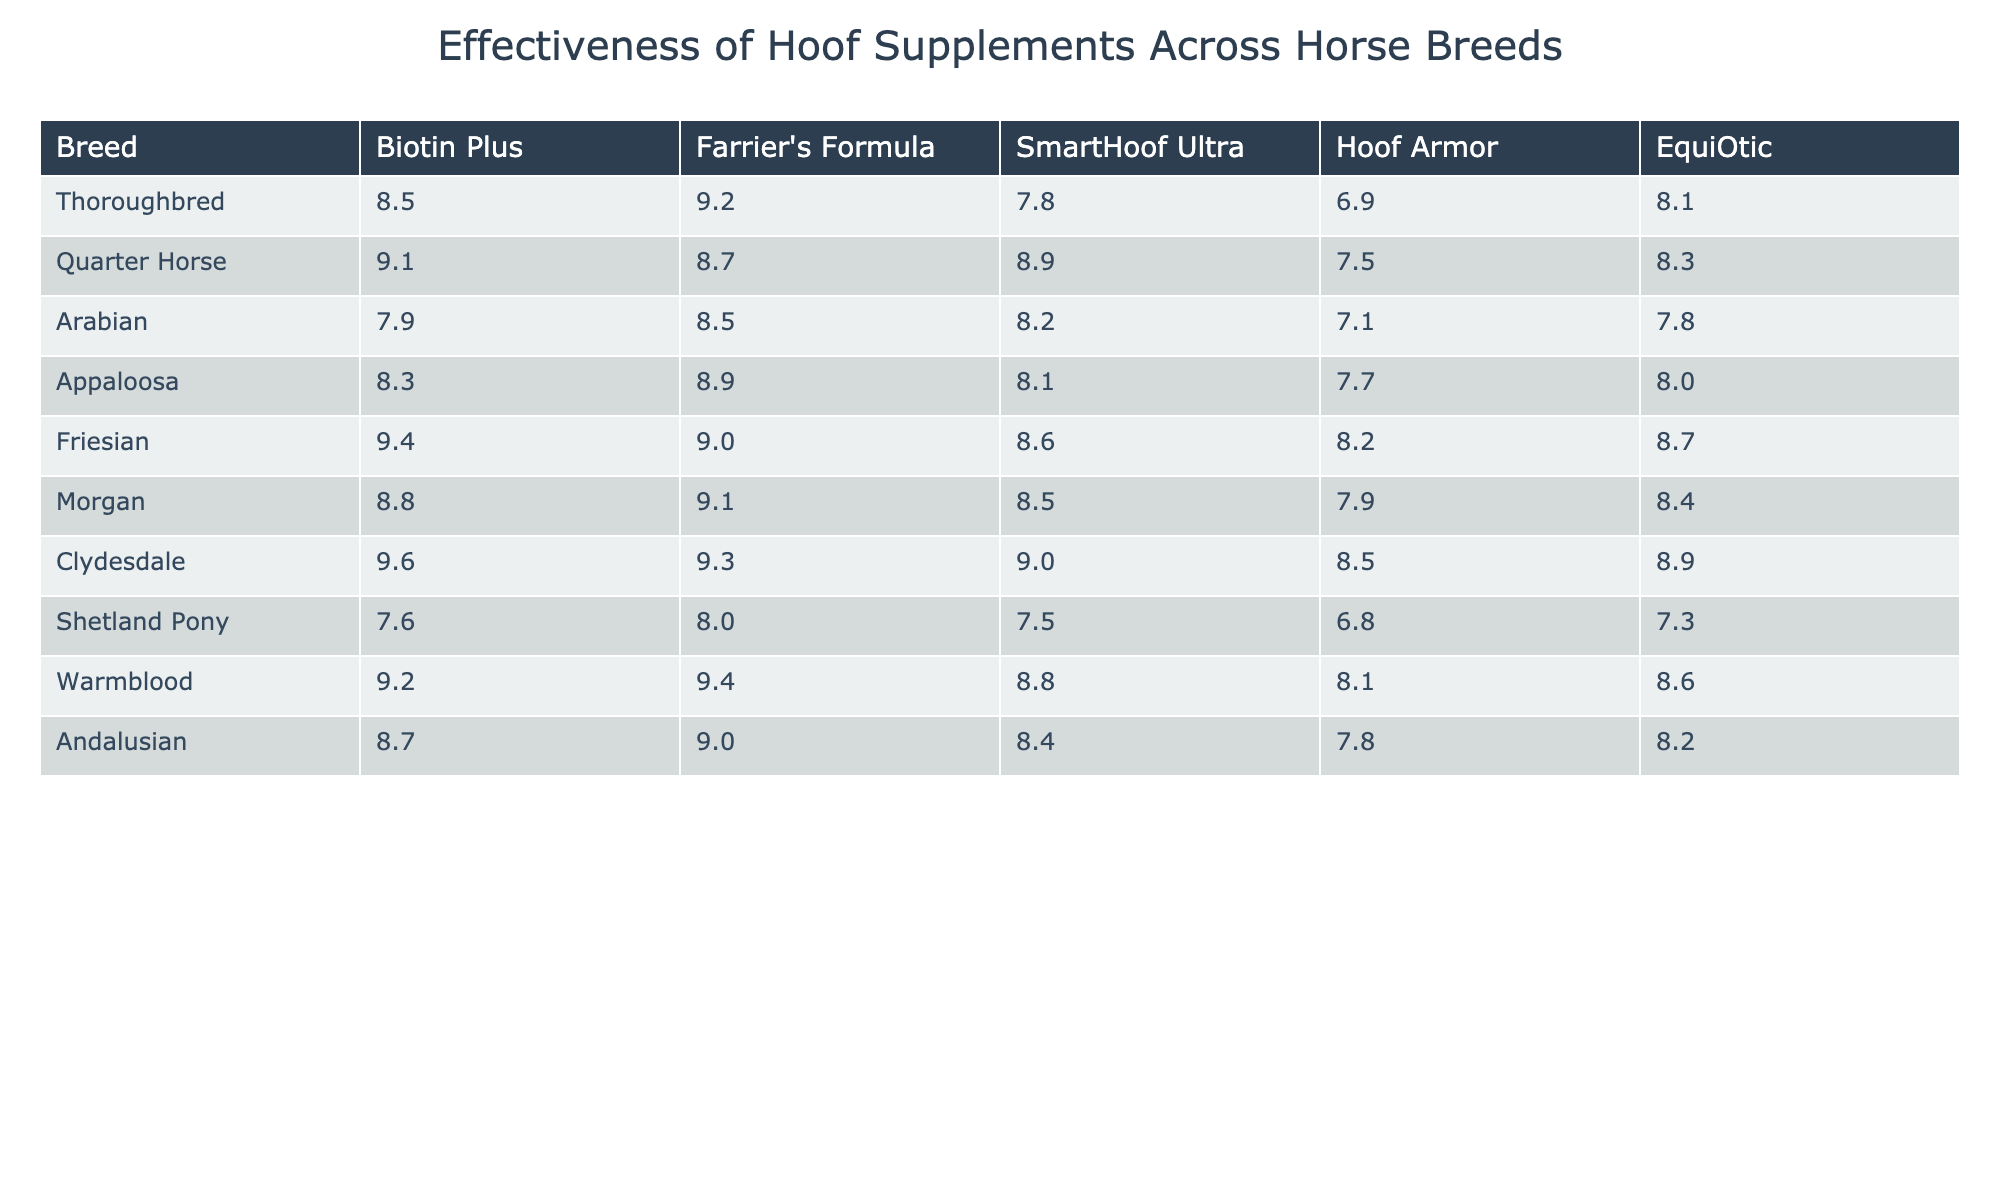What is the highest score for the Clydesdale breed across all supplements? The Clydesdale breed has scores of 9.6 for Biotin Plus, 9.3 for Farrier's Formula, 9.0 for SmartHoof Ultra, 8.5 for Hoof Armor, and 8.9 for EquiOtic. Among these, 9.6 is the highest score for the Clydesdale breed.
Answer: 9.6 Which hoof supplement scored the lowest for the Appaloosa breed? The Appaloosa breed has scores of 8.3 for Biotin Plus, 8.9 for Farrier's Formula, 8.1 for SmartHoof Ultra, 7.7 for Hoof Armor, and 8.0 for EquiOtic. The lowest score here is 7.7, corresponding to Hoof Armor.
Answer: Hoof Armor What is the average score for all hoof supplements for the Thoroughbred breed? The scores for Thoroughbred are 8.5, 9.2, 7.8, 6.9, and 8.1. Summing these gives 40.5, and dividing by 5 gives an average of 40.5 / 5 = 8.1.
Answer: 8.1 Is Farrier's Formula more effective than Biotin Plus for the Arabian breed? The Arabian breed has a score of 8.5 for Farrier's Formula and 7.9 for Biotin Plus. Since 8.5 is greater than 7.9, Farrier's Formula is more effective for the Arabian breed.
Answer: Yes Which hoof supplement has the highest average score across all breeds? To find the average, we calculate the total for each supplement: Biotin Plus (8.5 + 9.1 + 7.9 + 8.3 + 9.4 + 8.8 + 9.6 + 7.6 + 9.2 + 8.7) = 88.1; Farrier's Formula (9.2 + 8.7 + 8.5 + 8.9 + 9.0 + 9.1 + 9.3 + 8.0 + 9.4 + 9.0) = 88.1; SmartHoof Ultra (7.8 + 8.9 + 8.2 + 8.1 + 8.6 + 8.5 + 9.0 + 7.5 + 8.8 + 8.4) = 88.0; Hoof Armor (6.9 + 7.5 + 7.1 + 7.7 + 8.2 + 7.9 + 8.5 + 6.8 + 8.1 + 7.8) = 78.6; EquiOtic (8.1 + 8.3 + 7.8 + 8.0 + 8.7 + 8.4 + 8.9 + 7.3 + 8.6 + 8.2) = 86.3. The highest average is 88.1 for both Biotin Plus and Farrier's Formula.
Answer: Biotin Plus and Farrier's Formula What is the difference in scores between the best and worst supplements for the Quarter Horse? The Quarter Horse scores are 9.1 for Biotin Plus, 8.7 for Farrier's Formula, 8.9 for SmartHoof Ultra, 7.5 for Hoof Armor, and 8.3 for EquiOtic. The best score is 9.1 and the worst is 7.5. The difference is 9.1 - 7.5 = 1.6.
Answer: 1.6 Do all breeds have a score above 7 for SmartHoof Ultra? The scores for SmartHoof Ultra across the breeds are 7.8 (Thoroughbred), 8.9 (Quarter Horse), 8.2 (Arabian), 8.1 (Appaloosa), 8.6 (Friesian), 8.5 (Morgan), 9.0 (Clydesdale), 7.5 (Shetland Pony), 8.8 (Warmblood), and 8.4 (Andalusian). The Shetland Pony has a score of 7.5, which is below 7, thus not all breeds exceed 7.
Answer: No What is the relationship between EquiOtic and Hoof Armor scores for the Friesian breed? The Friesian breed has a score of 8.7 for EquiOtic and 8.2 for Hoof Armor. This shows that EquiOtic (8.7) is more effective than Hoof Armor (8.2) for the Friesian breed.
Answer: EquiOtic is more effective 